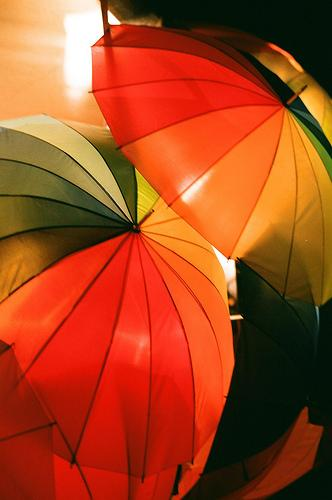Describe the sentiment depicted in the image based on the details provided. The sentiment of the image is positive and uplifting, as it showcases a colorful array of open umbrellas, possibly symbolizing protection and brightness. What is the most noticeable color among the umbrellas and where is it located? Orange is the most noticeable color, visible in the umbrellas located at coordinates (20, 100) and (203, 141). What complex reasoning task can be derived from the provided information about the image? A complex reasoning task from the image could be, "Understand the symbolism of the umbrellas' arrangement and colors in relation to the physical setting and light sources." What is the main subject of the image and how are the objects arranged? The main subject is a collection of open umbrellas of different colors, arranged close together on a wooden floor. What can you say about the umbrella with rainbow colors? The rainbow-colored umbrella has panels of red, yellow, orange, green, white, and grey, with a black portion too, and metal connectors on top. Analyze the interaction between the colorful umbrellas in the image. The colorful umbrellas are interacting closely, with panels touching, as they are grouped together in an open arrangement on the wooden floor. Is there any mention of light sources in the image's information? Yes, there is a frosted bright light at coordinates (65, 8), a bright light behind an orange panel at coordinates (173, 163), and light shining in the background at coordinates (59, 11). Qualitatively assess the image's visual quality based on the provided information. Due to the presence of bright light sources, a colorful subject, and a wooden background, the image's visual quality is likely to be high and appealing. Can you count how many umbrellas are in the image based on the provided information? It is not possible to accurately count the total number of umbrellas based on the provided information. Based on given information, describe the texture of the floor where the umbrellas are placed. The floor on which the umbrellas are placed appears to be wooden in texture. 